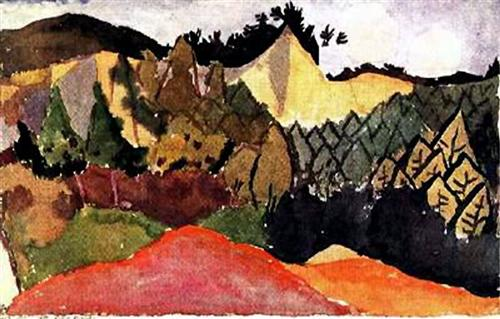Imagine you could step into this painting. What kind of adventure would you have? If I could step into this painting, I imagine embarking on a journey through the vibrant and varied landscape. Starting in the valley, I would walk through the rich reds and greens, feeling the energy and warmth of the colors around me. As I head toward the mountains, the terrain would become more rugged, and I would encounter a series of natural sculptures formed by the expressive brushstrokes. The play of light and shadow would create hidden paths and secret spots to explore, each turn revealing a new and captivating aspect of the scenery. Reaching the peak, I would look back at the valley, now a harmonious blend of vivid colors and dynamic shapes, feeling a sense of accomplishment and awe at the beauty of the world rendered in such a unique and evocative style. How would you describe the atmosphere of this place if it were real? The atmosphere of this place would likely be one of lively vitality mixed with serene tranquility. The vivid colors and energetic brushstrokes would translate to a landscape brimming with life and motion. Imagine a warm, inviting environment where every element, from the smallest leaf to the tallest peak, seems to pulse with vivid energy. The red hues would imbue the landscape with warmth, perhaps suggesting a sunny, late summer or early autumn day. The greens would offer a sense of freshness and growth, while the deeper shadows might hint at the cool, tranquil retreats within the forest. Overall, it would be a place that feels both exhilarating and peaceful, a perfect balance of nature's dynamism and calm. 